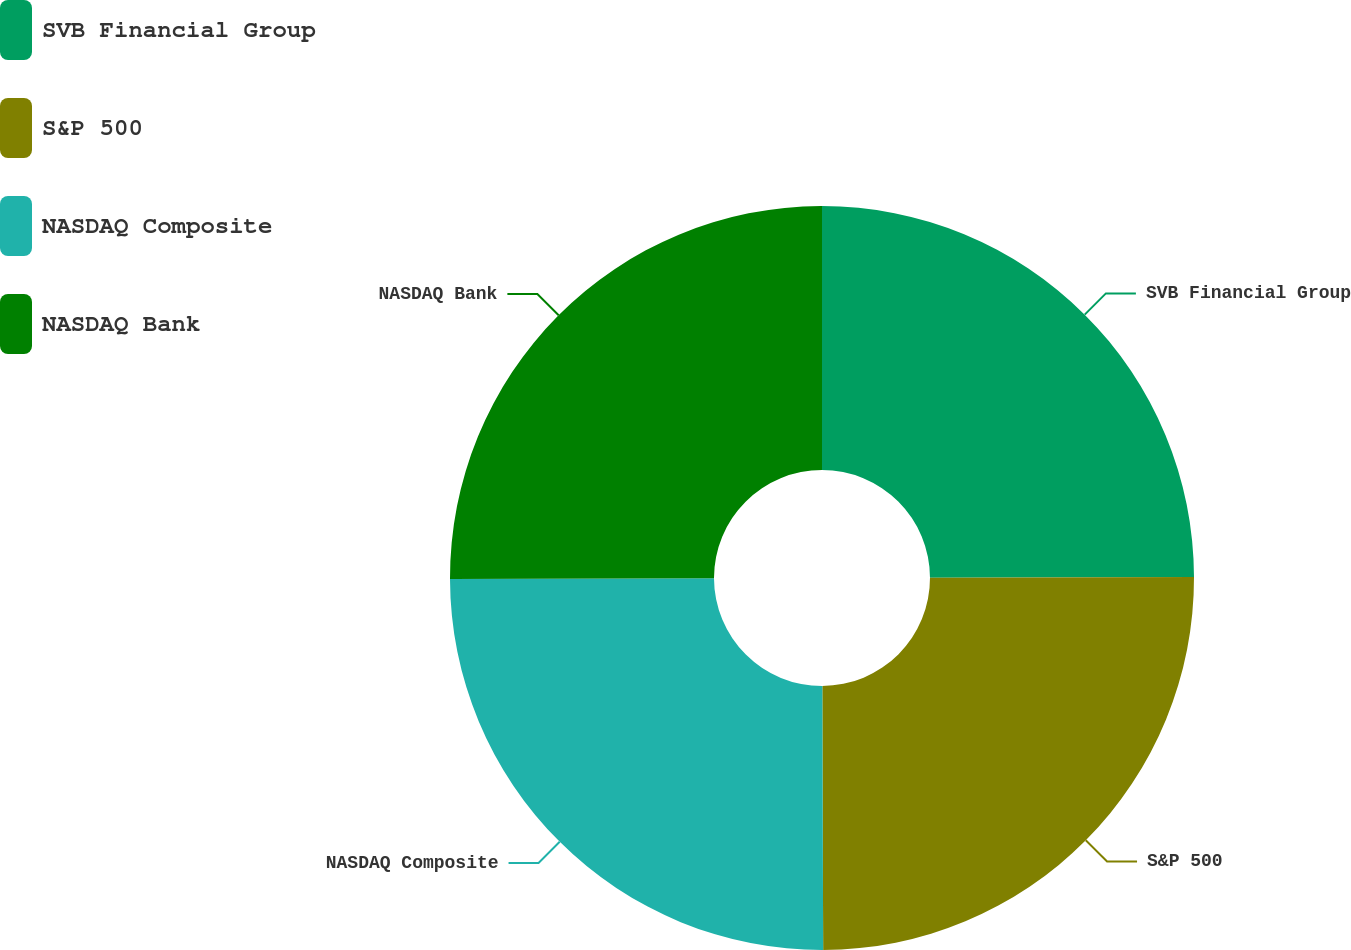<chart> <loc_0><loc_0><loc_500><loc_500><pie_chart><fcel>SVB Financial Group<fcel>S&P 500<fcel>NASDAQ Composite<fcel>NASDAQ Bank<nl><fcel>24.96%<fcel>24.99%<fcel>25.01%<fcel>25.04%<nl></chart> 